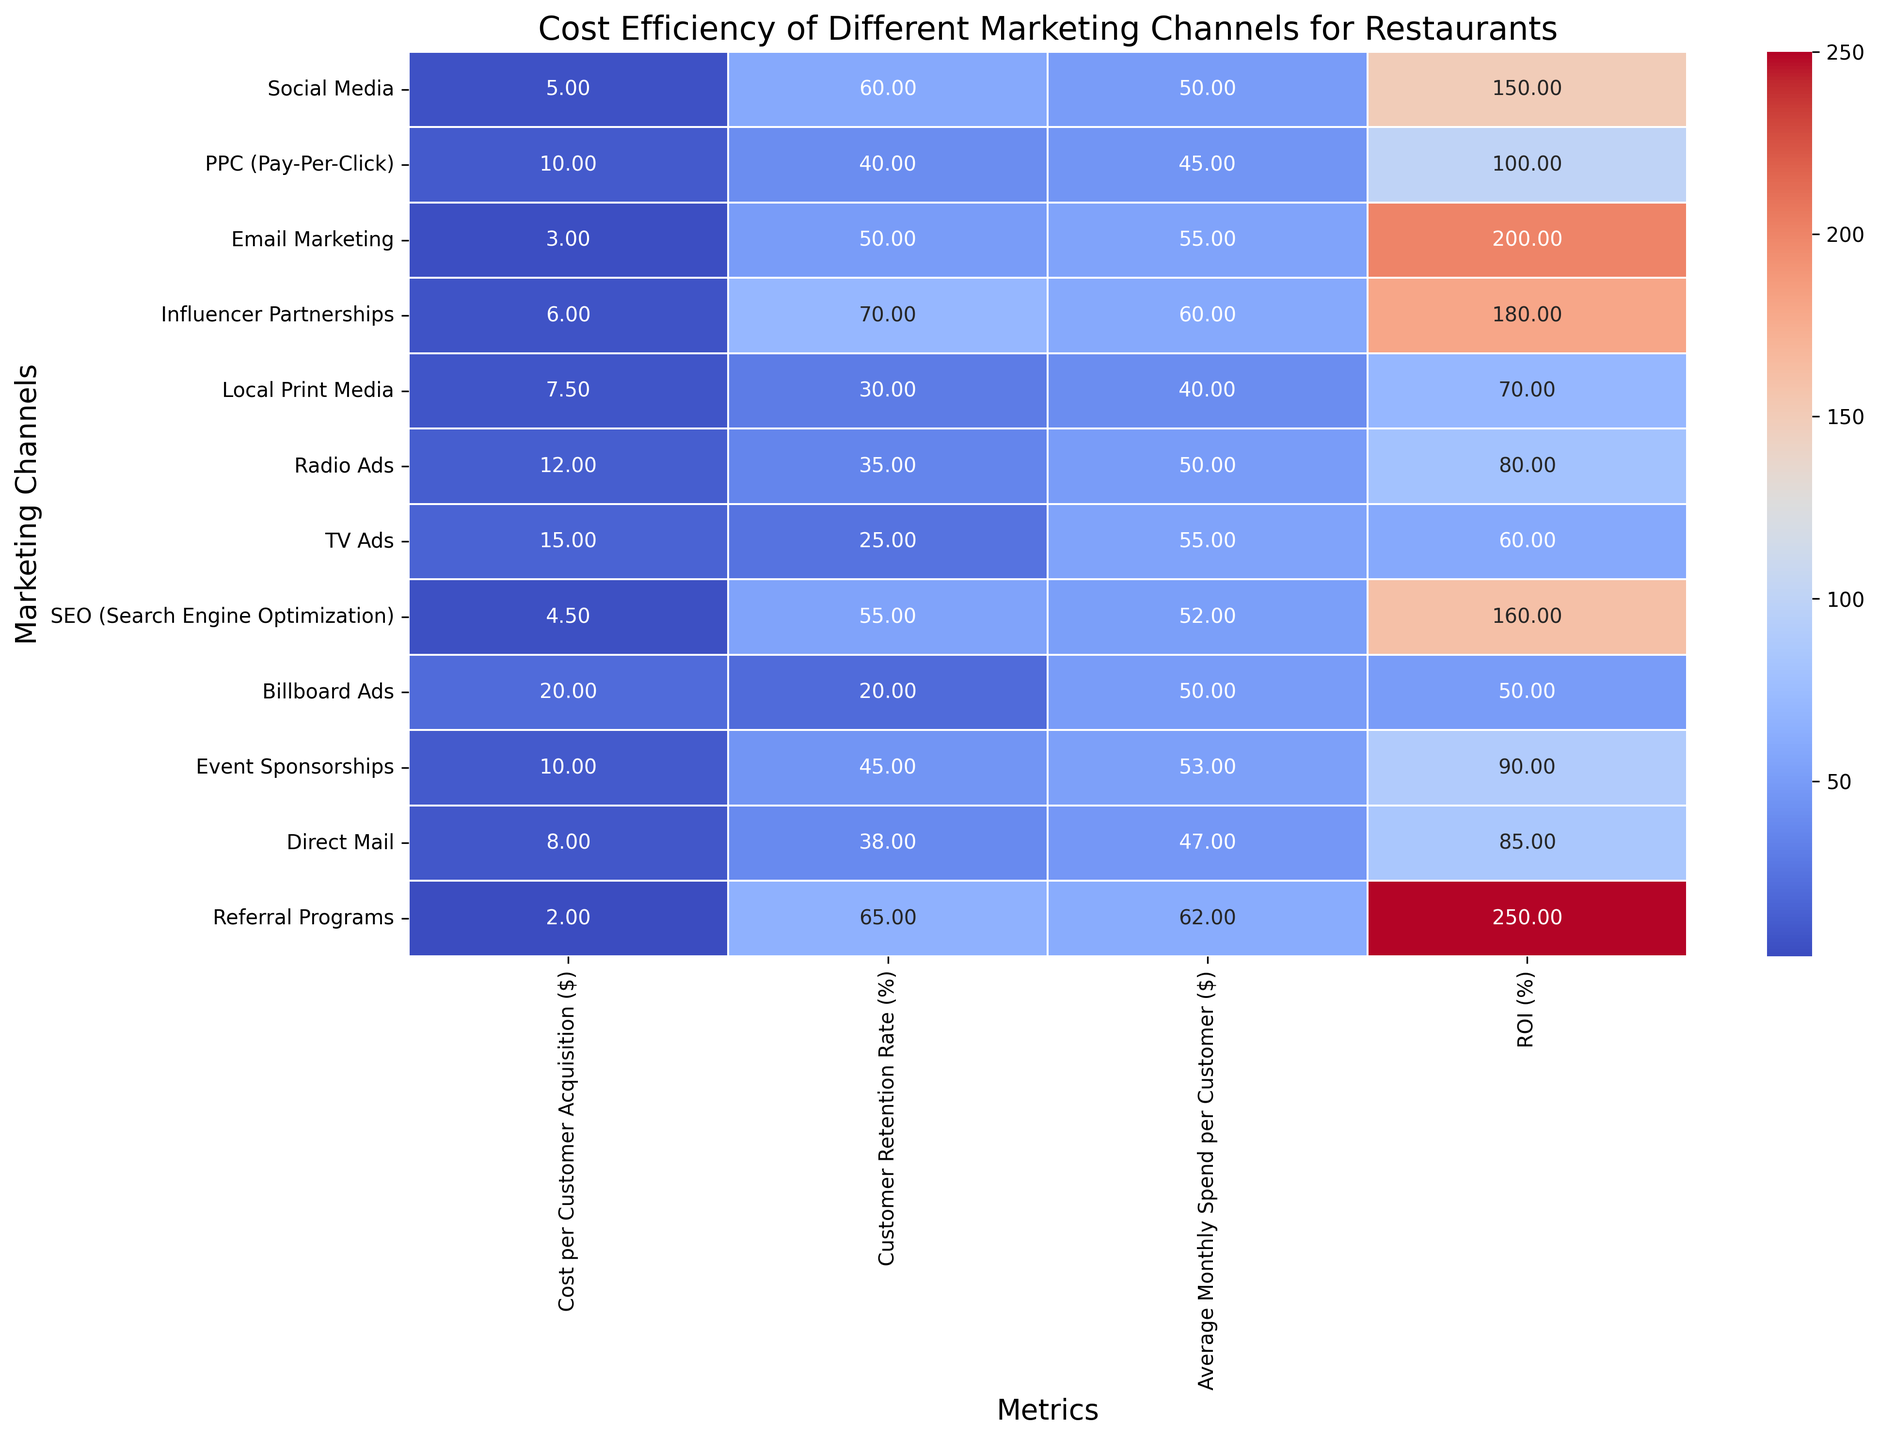Which marketing channel has the highest ROI? The ROI percentages are displayed across all channels. The highest ROI value will be the one with the largest percentage. From the heatmap, 'Referral Programs' with an ROI of 250% has the highest ROI.
Answer: Referral Programs Which marketing channel has the lowest customer retention rate? The customer retention rates are displayed as percentages. The lowest value will be the smallest number in the Customer Retention Rate column. The lowest retention rate is 20% for 'Billboard Ads'.
Answer: Billboard Ads Which two marketing channels have the closest Cost per Customer Acquisition values? The cost per customer acquisition values are displayed in dollars across the channels. We need to compare the values and find the smallest difference. 'Email Marketing' and 'SEO' have costs of $3.00 and $4.50 respectively, which are closest.
Answer: Email Marketing and SEO What is the difference in ROI between Social Media and TV Ads? We look at the ROI percentages for Social Media and TV Ads. Social Media has an ROI of 150% and TV Ads have an ROI of 60%. The difference is 150% - 60% = 90%.
Answer: 90% Which channel has the highest Average Monthly Spend per Customer? The highest spend per customer is represented by the largest value in the Average Monthly Spend per Customer column. 'Influencer Partnerships' with $60 per customer has the highest value.
Answer: Influencer Partnerships Which marketing channel offers the best customer retention rate relative to Cost per Customer Acquisition? We calculate the ratio of Customer Retention Rate to the Cost per Customer Acquisition. 'Referral Programs' has a retention rate of 65% and a cost of $2.00, giving a ratio of 65 / 2 = 32.5, the highest among all channels.
Answer: Referral Programs Is the Cost per Customer Acquisition for TV Ads greater than for Radio Ads? Compare the cost values for TV Ads and Radio Ads. TV Ads have a cost of $15.00 per acquisition, while Radio Ads have a cost of $12.00. Because $15.00 > $12.00, TV Ads have a higher cost.
Answer: Yes Which channel has a better retention rate: Email Marketing or PPC? Compare the retention rates for Email Marketing and PPC. Email Marketing has 50% and PPC has 40%. Since 50% > 40%, Email Marketing has a better retention rate.
Answer: Email Marketing What is the combined Average Monthly Spend per Customer for Email Marketing and Radio Ads? Add the average spend values for both channels. Email Marketing has $55 and Radio Ads have $50. Combined, it's $55 + $50 = $105.
Answer: $105 